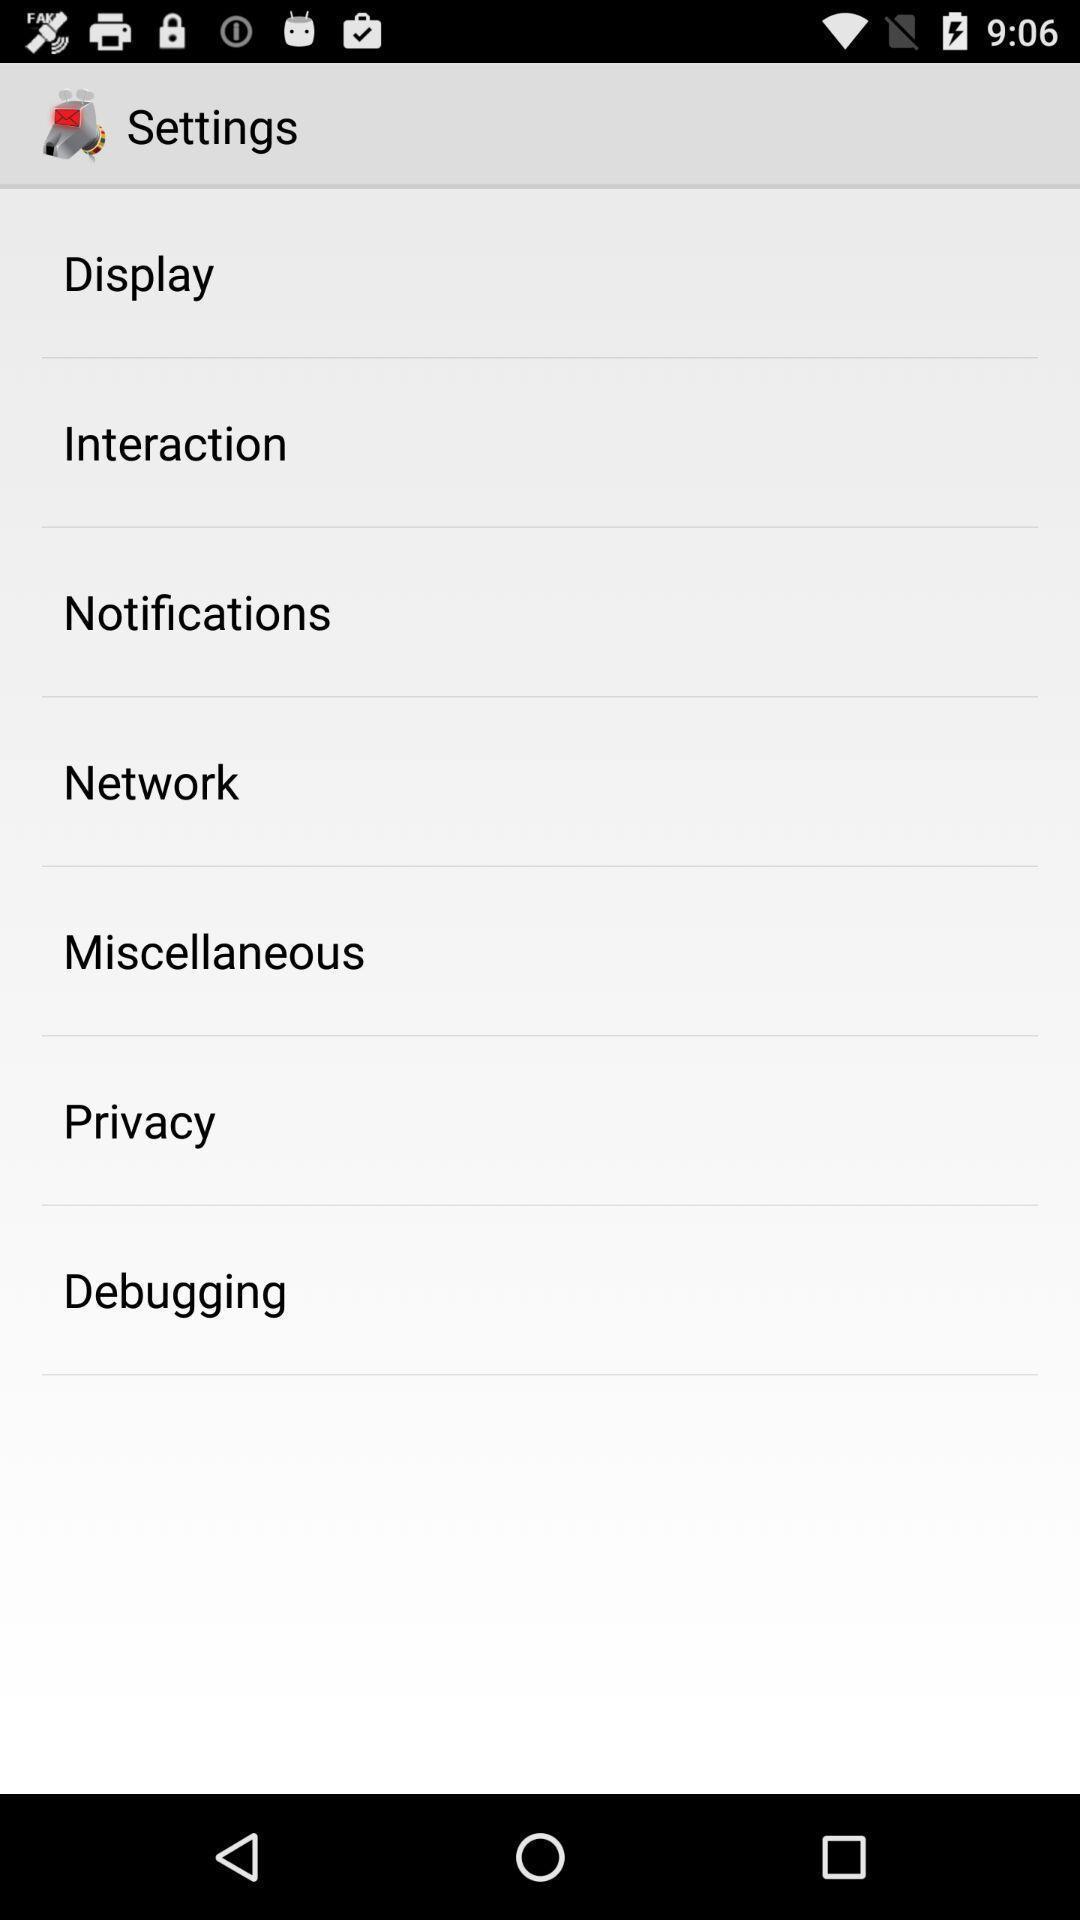Give me a narrative description of this picture. Settings page with different options displayed. 